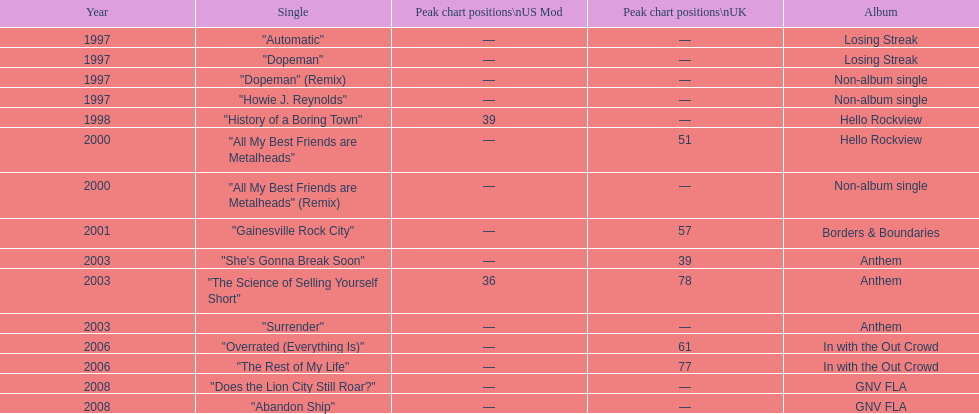Could you parse the entire table as a dict? {'header': ['Year', 'Single', 'Peak chart positions\\nUS Mod', 'Peak chart positions\\nUK', 'Album'], 'rows': [['1997', '"Automatic"', '—', '—', 'Losing Streak'], ['1997', '"Dopeman"', '—', '—', 'Losing Streak'], ['1997', '"Dopeman" (Remix)', '—', '—', 'Non-album single'], ['1997', '"Howie J. Reynolds"', '—', '—', 'Non-album single'], ['1998', '"History of a Boring Town"', '39', '—', 'Hello Rockview'], ['2000', '"All My Best Friends are Metalheads"', '—', '51', 'Hello Rockview'], ['2000', '"All My Best Friends are Metalheads" (Remix)', '—', '—', 'Non-album single'], ['2001', '"Gainesville Rock City"', '—', '57', 'Borders & Boundaries'], ['2003', '"She\'s Gonna Break Soon"', '—', '39', 'Anthem'], ['2003', '"The Science of Selling Yourself Short"', '36', '78', 'Anthem'], ['2003', '"Surrender"', '—', '—', 'Anthem'], ['2006', '"Overrated (Everything Is)"', '—', '61', 'In with the Out Crowd'], ['2006', '"The Rest of My Life"', '—', '77', 'In with the Out Crowd'], ['2008', '"Does the Lion City Still Roar?"', '—', '—', 'GNV FLA'], ['2008', '"Abandon Ship"', '—', '—', 'GNV FLA']]} What was the average chart placement of their singles in the united kingdom? 60.5. 